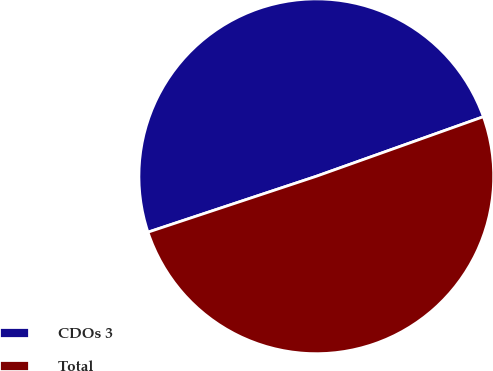Convert chart. <chart><loc_0><loc_0><loc_500><loc_500><pie_chart><fcel>CDOs 3<fcel>Total<nl><fcel>49.65%<fcel>50.35%<nl></chart> 